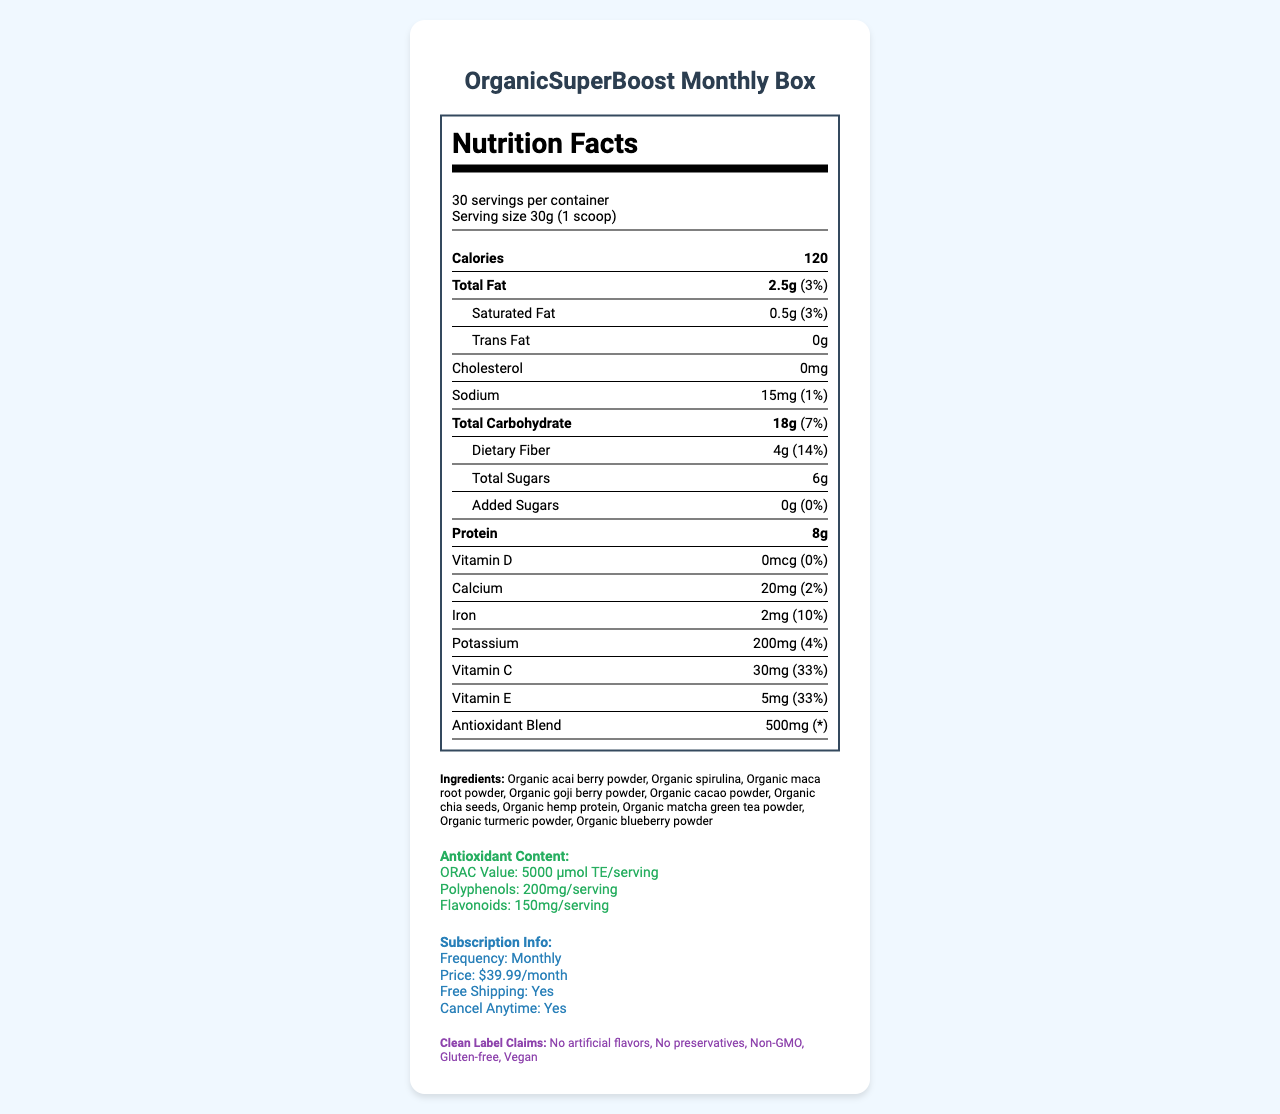what is the serving size? The serving size is mentioned at the top of the nutrition facts panel as "30g (1 scoop)".
Answer: 30g (1 scoop) how many calories are in one serving? The calories per serving are listed prominently in the nutrition facts section as "120".
Answer: 120 what is the amount of total carbohydrates per serving? The total carbohydrates per serving are given as "18g" in the nutrition facts section.
Answer: 18g how much protein does one serving contain? The protein content per serving is listed as "8g" in the nutrition facts section.
Answer: 8g which vitamins have a daily value percentage listed? The vitamins and minerals that have a daily value percentage listed include Vitamin C with 33%, Vitamin E with 33%, Calcium with 2%, Iron with 10%, and Potassium with 4%.
Answer: Vitamin C (33%), Vitamin E (33%), Calcium (2%), Iron (10%), Potassium (4%) what are the ingredients of the product? The ingredients are listed towards the end of the document and include various organic powders and seeds.
Answer: Organic acai berry powder, Organic spirulina, Organic maca root powder, Organic goji berry powder, Organic cacao powder, Organic chia seeds, Organic hemp protein, Organic matcha green tea powder, Organic turmeric powder, Organic blueberry powder what is the ORAC Value of the antioxidant content? The ORAC Value is listed in the antioxidant content section as "5000 μmol TE/serving".
Answer: 5000 μmol TE/serving which nutrients do not contain any daily value percentage? The nutrients listed without a daily value percentage include Trans Fat, Cholesterol, Total Sugars, Added Sugars, Vitamin D, and Antioxidant Blend.
Answer: Trans Fat, Cholesterol, Total Sugars, Added Sugars, Vitamin D, Antioxidant Blend what is the price per month for the subscription? The subscription price is listed in the subscription info section as "$39.99/month".
Answer: $39.99/month can subscribers customize their box contents each month? The subscription info section states "Customize your box contents each month", indicating that customization is possible.
Answer: Yes which customer retention feature offers a discount for referrals? The customer retention features section mentions "Referral program: Get $10 off your next box when you refer a friend", indicating a discount for referrals.
Answer: Referral program What is the daily value percentage of dietary fiber per serving?
A. 10%
B. 11%
C. 14%
D. 15% The daily value percentage of dietary fiber per serving is listed as 14% in the nutrition facts section.
Answer: C Which of the following clean label claims is NOT mentioned in the document?
1. Vegan
2. Gluten-free
3. Sugar-free
4. Non-GMO The clean label claims listed include "No artificial flavors", "No preservatives", "Non-GMO", "Gluten-free", and "Vegan", but not "Sugar-free".
Answer: 3 Is the packaging of this product recyclable? The sustainability info section mentions "100% recyclable and compostable packaging", indicating that the packaging is recyclable.
Answer: Yes Summarize the main features of the OrganicSuperBoost Monthly Box. The document provides detailed information about the product's nutritional values, antioxidant content, ingredients, subscription options, customer retention features, clean-label claims, and sustainability measures.
Answer: The OrganicSuperBoost Monthly Box contains a serving size of 30g (1 scoop) with 120 calories. It includes various organic ingredients like acai berry powder and spirulina, and provides information on antioxidants, vitamins, and minerals. The subscription costs $39.99 per month with features like free shipping and customization options. Customer retention features include earning loyalty points, a referral program, and access to nutrition workshops. The product also emphasizes clean-label claims and sustainability features. How many years has OrganicSuperBoost Monthly Box been on the market? The document does not provide any information regarding the time duration the product has been available on the market.
Answer: Cannot be determined 